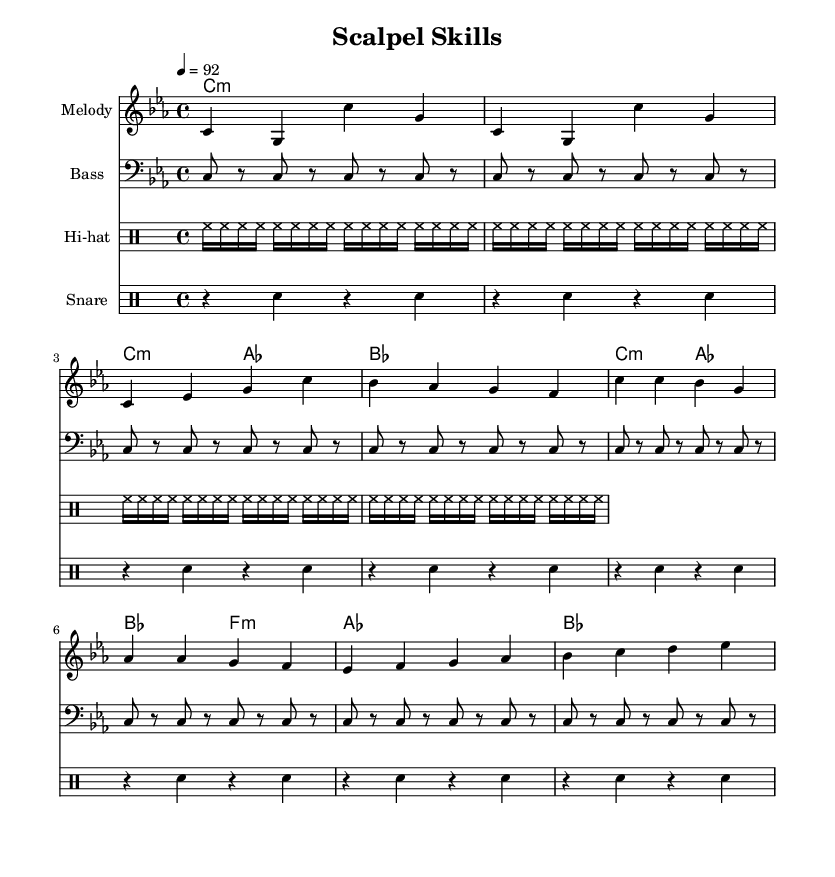What is the key signature of this music? The key signature is C minor, which has three flats (B flat, E flat, and A flat). This can be identified at the beginning of the score, where the key signature is displayed.
Answer: C minor What is the time signature of this music? The time signature is 4/4, indicated at the start of the score. This means there are four beats per measure, with each quarter note receiving one beat.
Answer: 4/4 What is the tempo marking of this music? The tempo marking is 92 beats per minute, noted above the staff where it states the speed of the piece.
Answer: 92 How many measures are in the melody section? The melody section consists of 8 measures, as counted through the sequential groupings of bars in the melody notation.
Answer: 8 Which musical genre does this score represent? The score is explicitly identified as a rap song, as indicated by the title "Scalpel Skills" and the content, which focuses on themes related to the dedication needed to become a surgeon in a rap format.
Answer: Rap What type of rhythm predominates in the hihat section? The rhythm in the hihat section features continuous sixteenth notes, creating a steady and upbeat driving rhythm typical in rap music. This is evident in the drummode notation which shows successive hihat hits.
Answer: Sixteenth notes 